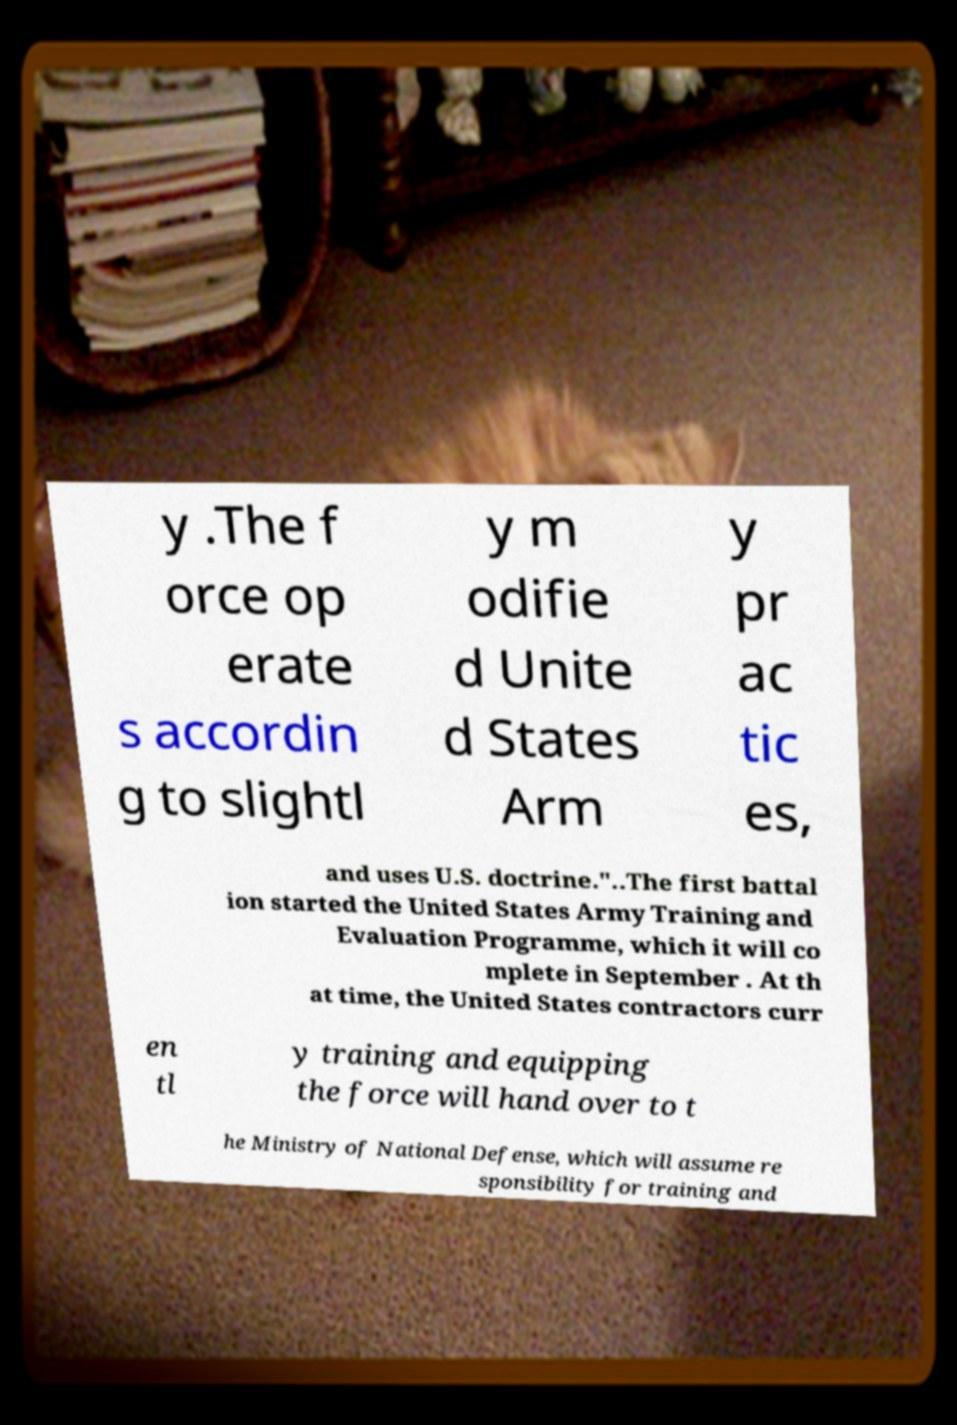What messages or text are displayed in this image? I need them in a readable, typed format. y .The f orce op erate s accordin g to slightl y m odifie d Unite d States Arm y pr ac tic es, and uses U.S. doctrine."..The first battal ion started the United States Army Training and Evaluation Programme, which it will co mplete in September . At th at time, the United States contractors curr en tl y training and equipping the force will hand over to t he Ministry of National Defense, which will assume re sponsibility for training and 